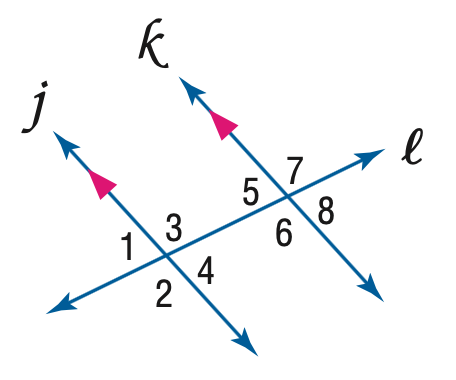Answer the mathemtical geometry problem and directly provide the correct option letter.
Question: If m \angle 2 = 4 x + 7 and m \angle 7 = 5 x - 13, find x.
Choices: A: 6 B: 19 C: 20 D: 21 C 